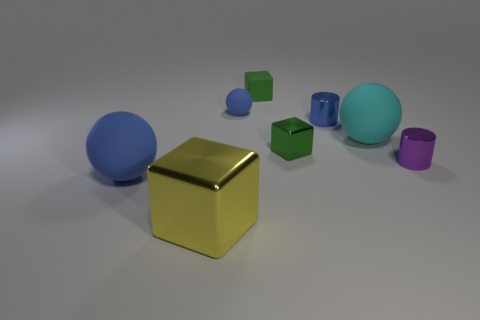Is the size of the green matte object the same as the shiny block that is right of the yellow shiny object?
Offer a very short reply. Yes. There is a metallic thing that is behind the tiny block on the right side of the small green object behind the tiny blue matte object; what is its size?
Provide a short and direct response. Small. There is a metal cylinder in front of the tiny blue cylinder; what size is it?
Offer a terse response. Small. What shape is the blue object that is the same material as the big cube?
Ensure brevity in your answer.  Cylinder. Do the big cyan object in front of the small blue metallic object and the purple cylinder have the same material?
Your response must be concise. No. What number of other things are the same material as the big blue object?
Offer a terse response. 3. What number of objects are large objects to the left of the green rubber block or cylinders behind the green metallic object?
Your answer should be compact. 3. Do the tiny green thing that is in front of the tiny blue metallic cylinder and the shiny thing to the left of the matte block have the same shape?
Keep it short and to the point. Yes. What shape is the blue rubber object that is the same size as the purple metallic thing?
Offer a very short reply. Sphere. How many matte objects are either big green balls or small blocks?
Ensure brevity in your answer.  1. 